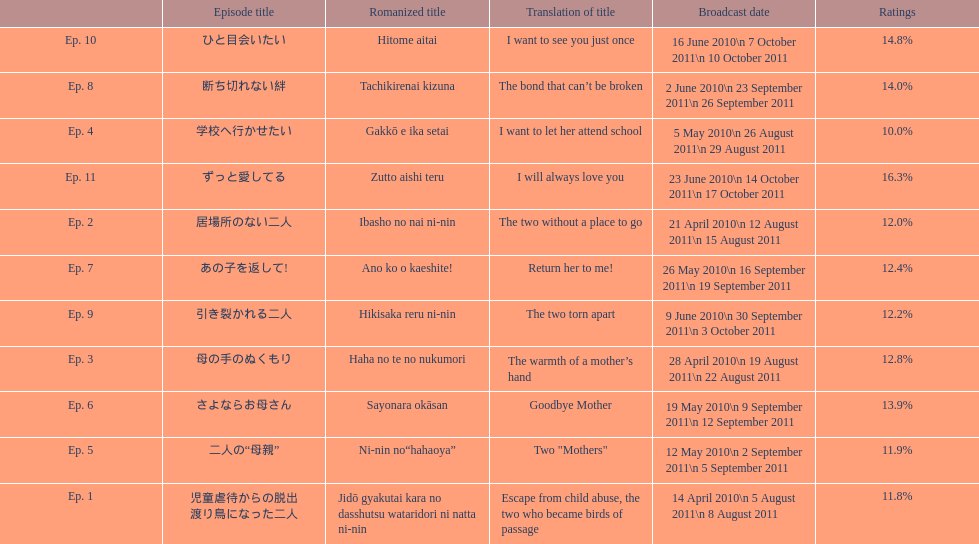What as the percentage total of ratings for episode 8? 14.0%. 